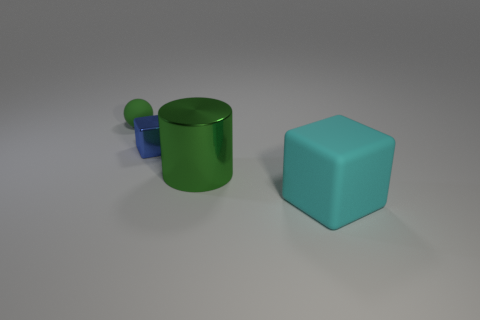Add 4 green objects. How many objects exist? 8 Subtract all spheres. How many objects are left? 3 Subtract 0 red blocks. How many objects are left? 4 Subtract all small matte cylinders. Subtract all small green rubber spheres. How many objects are left? 3 Add 4 small blue metallic cubes. How many small blue metallic cubes are left? 5 Add 3 large shiny things. How many large shiny things exist? 4 